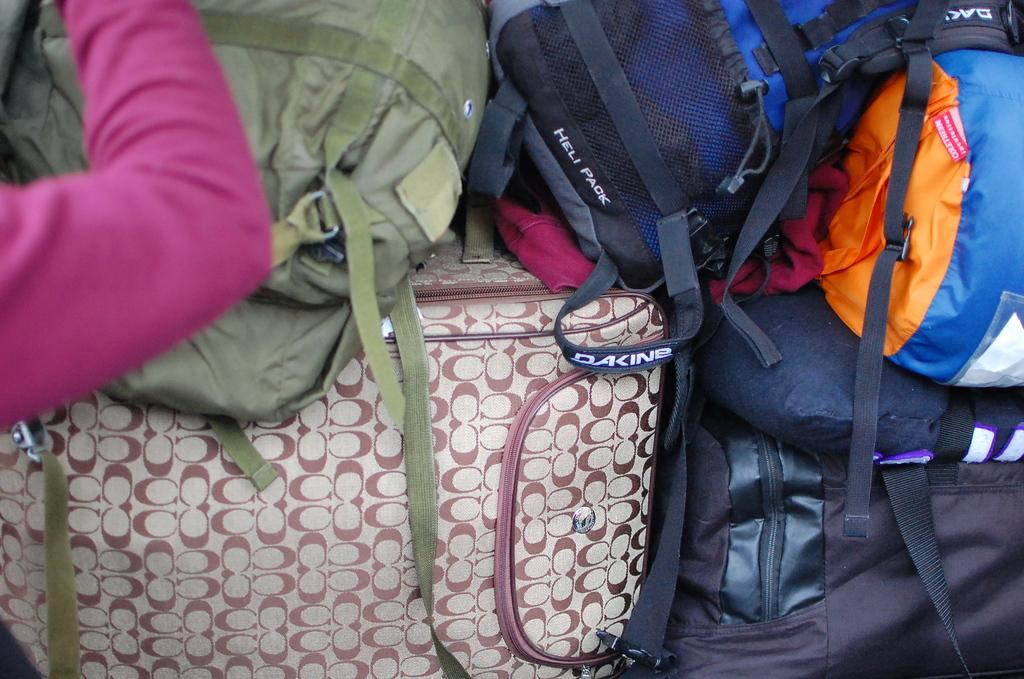What objects are present in the image? There are many bags in the image. Can you describe any other elements in the image? A person's hand is visible in the image. What type of soup is being served in the image? There is no soup present in the image; it only features bags and a person's hand. 